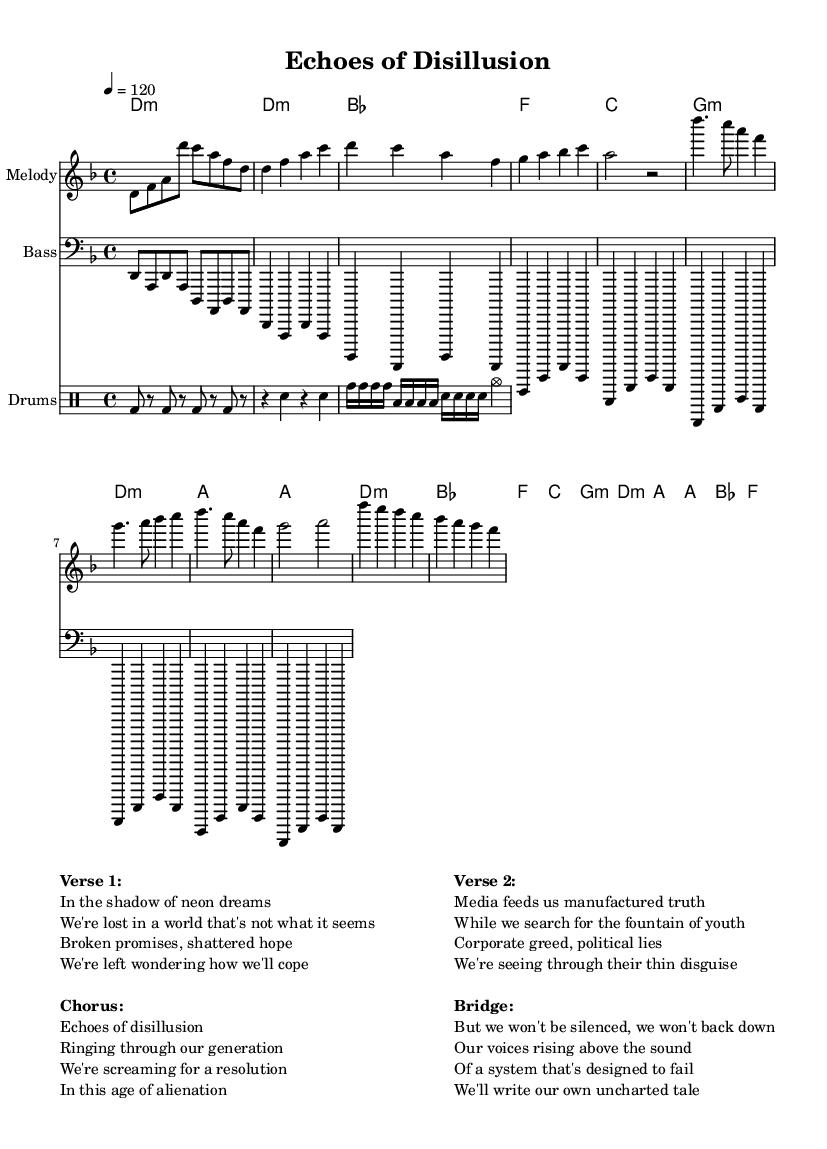What is the key signature of this music? The key signature indicates that the piece is in D minor, which has one flat (B flat). This can be identified by looking at the beginning of the staff where the key signature is usually displayed.
Answer: D minor What is the time signature of this piece? The time signature shows that this music is written in 4/4 time, which means there are four beats in each measure and the quarter note gets one beat. This can be found at the beginning of the score.
Answer: 4/4 What is the tempo marking for the music? The tempo marking indicates that the music should be played at a speed of 120 beats per minute, which is defined in the tempo section found at the start of the score.
Answer: 120 Which section of the song includes the lyrics "Echoes of disillusion"? The phrase "Echoes of disillusion" appears in the Chorus section, where distinct lines of lyrics are provided after the verse text, allowing the conclusion to enhance the song's theme.
Answer: Chorus How many measures are in the verse section? The verse section has a total of four measures, which can be counted by identifying the bar lines that separate the sections in the melody part of the sheet music.
Answer: 4 What is the dominant chord used in the chorus? The dominant chord in D minor is A major, which is generally expected in the chorus section as it resolves the progression leading back to D minor, making it the focus of the resolution.
Answer: A What lyrical theme is presented in the bridge? The theme presented in the bridge discusses resilience and empowerment, focusing on not being silenced and rising above challenges, which is emphasized in the powerful wording of the lyrics.
Answer: Resilience 